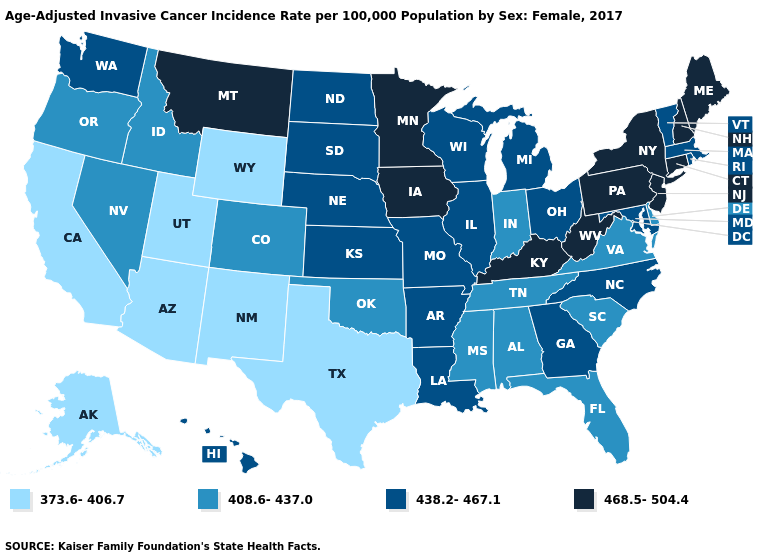Does Ohio have the highest value in the USA?
Quick response, please. No. What is the lowest value in states that border North Carolina?
Concise answer only. 408.6-437.0. Does Maryland have a lower value than Connecticut?
Be succinct. Yes. Name the states that have a value in the range 438.2-467.1?
Give a very brief answer. Arkansas, Georgia, Hawaii, Illinois, Kansas, Louisiana, Maryland, Massachusetts, Michigan, Missouri, Nebraska, North Carolina, North Dakota, Ohio, Rhode Island, South Dakota, Vermont, Washington, Wisconsin. Name the states that have a value in the range 373.6-406.7?
Write a very short answer. Alaska, Arizona, California, New Mexico, Texas, Utah, Wyoming. Name the states that have a value in the range 438.2-467.1?
Concise answer only. Arkansas, Georgia, Hawaii, Illinois, Kansas, Louisiana, Maryland, Massachusetts, Michigan, Missouri, Nebraska, North Carolina, North Dakota, Ohio, Rhode Island, South Dakota, Vermont, Washington, Wisconsin. Name the states that have a value in the range 373.6-406.7?
Short answer required. Alaska, Arizona, California, New Mexico, Texas, Utah, Wyoming. Name the states that have a value in the range 438.2-467.1?
Concise answer only. Arkansas, Georgia, Hawaii, Illinois, Kansas, Louisiana, Maryland, Massachusetts, Michigan, Missouri, Nebraska, North Carolina, North Dakota, Ohio, Rhode Island, South Dakota, Vermont, Washington, Wisconsin. Name the states that have a value in the range 438.2-467.1?
Concise answer only. Arkansas, Georgia, Hawaii, Illinois, Kansas, Louisiana, Maryland, Massachusetts, Michigan, Missouri, Nebraska, North Carolina, North Dakota, Ohio, Rhode Island, South Dakota, Vermont, Washington, Wisconsin. What is the value of Arkansas?
Be succinct. 438.2-467.1. What is the highest value in the USA?
Write a very short answer. 468.5-504.4. Is the legend a continuous bar?
Concise answer only. No. What is the value of North Carolina?
Answer briefly. 438.2-467.1. Name the states that have a value in the range 468.5-504.4?
Short answer required. Connecticut, Iowa, Kentucky, Maine, Minnesota, Montana, New Hampshire, New Jersey, New York, Pennsylvania, West Virginia. Name the states that have a value in the range 438.2-467.1?
Quick response, please. Arkansas, Georgia, Hawaii, Illinois, Kansas, Louisiana, Maryland, Massachusetts, Michigan, Missouri, Nebraska, North Carolina, North Dakota, Ohio, Rhode Island, South Dakota, Vermont, Washington, Wisconsin. 